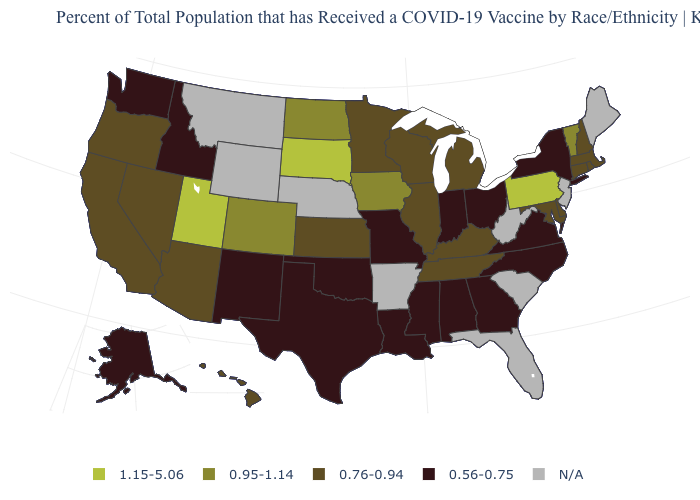Name the states that have a value in the range 0.56-0.75?
Write a very short answer. Alabama, Alaska, Georgia, Idaho, Indiana, Louisiana, Mississippi, Missouri, New Mexico, New York, North Carolina, Ohio, Oklahoma, Texas, Virginia, Washington. What is the value of Washington?
Give a very brief answer. 0.56-0.75. What is the value of Georgia?
Quick response, please. 0.56-0.75. Does the first symbol in the legend represent the smallest category?
Be succinct. No. What is the value of Oregon?
Concise answer only. 0.76-0.94. What is the lowest value in states that border South Carolina?
Be succinct. 0.56-0.75. Which states hav the highest value in the Northeast?
Short answer required. Pennsylvania. Which states have the lowest value in the USA?
Write a very short answer. Alabama, Alaska, Georgia, Idaho, Indiana, Louisiana, Mississippi, Missouri, New Mexico, New York, North Carolina, Ohio, Oklahoma, Texas, Virginia, Washington. Name the states that have a value in the range 1.15-5.06?
Concise answer only. Pennsylvania, South Dakota, Utah. Among the states that border Wisconsin , does Iowa have the lowest value?
Concise answer only. No. Does New Mexico have the lowest value in the West?
Quick response, please. Yes. What is the value of Ohio?
Be succinct. 0.56-0.75. Which states have the lowest value in the USA?
Quick response, please. Alabama, Alaska, Georgia, Idaho, Indiana, Louisiana, Mississippi, Missouri, New Mexico, New York, North Carolina, Ohio, Oklahoma, Texas, Virginia, Washington. What is the value of South Carolina?
Give a very brief answer. N/A. 